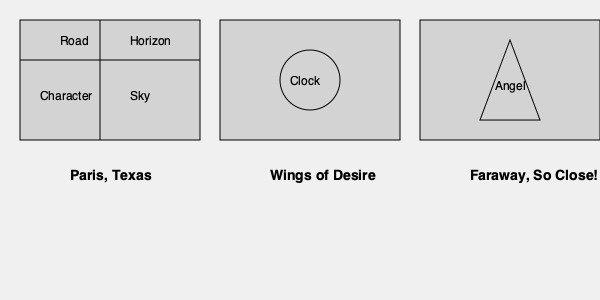Analyze the recurring visual motifs in Wim Wenders' films as represented in the storyboard sketches above. Identify the common theme that connects these motifs and explain how it reflects Wenders' auteur style. To analyze the recurring visual motifs in Wim Wenders' films based on the storyboard sketches, we need to follow these steps:

1. Identify the motifs:
   a) Paris, Texas: Road, horizon, character, and sky
   b) Wings of Desire: Clock
   c) Faraway, So Close!: Angel

2. Interpret the symbolism:
   a) Road and horizon: Represent journey, movement, and the search for identity
   b) Character and sky: Illustrate the relationship between individuals and their environment
   c) Clock: Symbolizes the passage of time and temporal dimensions
   d) Angel: Represents otherworldly perspectives and spiritual themes

3. Connect the motifs:
   All these motifs relate to the concept of perspective and the human experience of space and time.

4. Analyze Wenders' auteur style:
   a) Focus on existential themes
   b) Exploration of human condition in relation to landscape and time
   c) Interest in the interplay between earthly and spiritual realms
   d) Use of visual metaphors to convey philosophical ideas

5. Identify the common theme:
   The recurring motifs all contribute to Wenders' exploration of human existence, perception, and the search for meaning in a complex world.

6. Reflect on Wenders' artistic vision:
   These motifs demonstrate Wenders' consistent interest in examining the human experience through visual storytelling, blending physical and metaphysical elements to create a unique cinematic language.
Answer: Existential exploration through visual metaphors of space, time, and perspective 